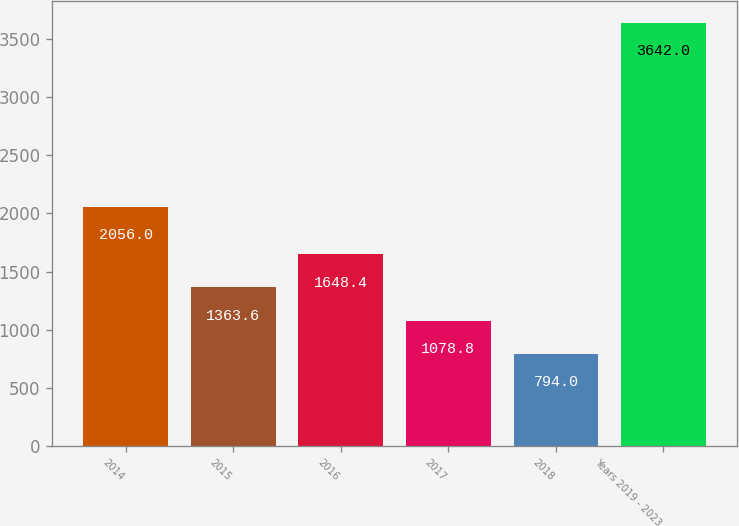<chart> <loc_0><loc_0><loc_500><loc_500><bar_chart><fcel>2014<fcel>2015<fcel>2016<fcel>2017<fcel>2018<fcel>Years 2019 - 2023<nl><fcel>2056<fcel>1363.6<fcel>1648.4<fcel>1078.8<fcel>794<fcel>3642<nl></chart> 